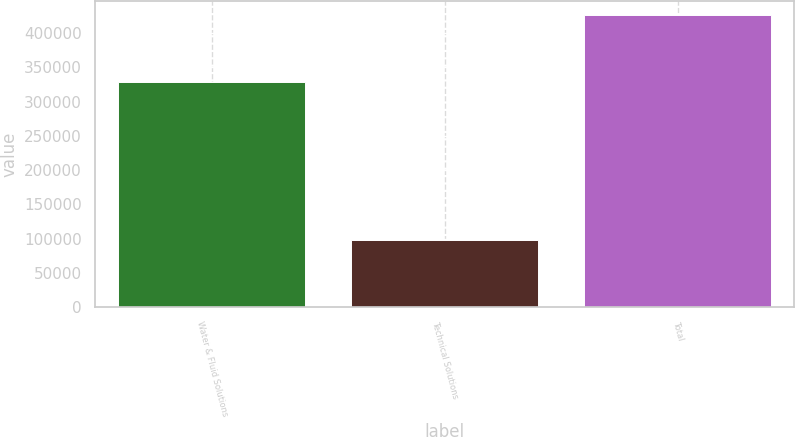Convert chart to OTSL. <chart><loc_0><loc_0><loc_500><loc_500><bar_chart><fcel>Water & Fluid Solutions<fcel>Technical Solutions<fcel>Total<nl><fcel>328523<fcel>97390<fcel>425913<nl></chart> 